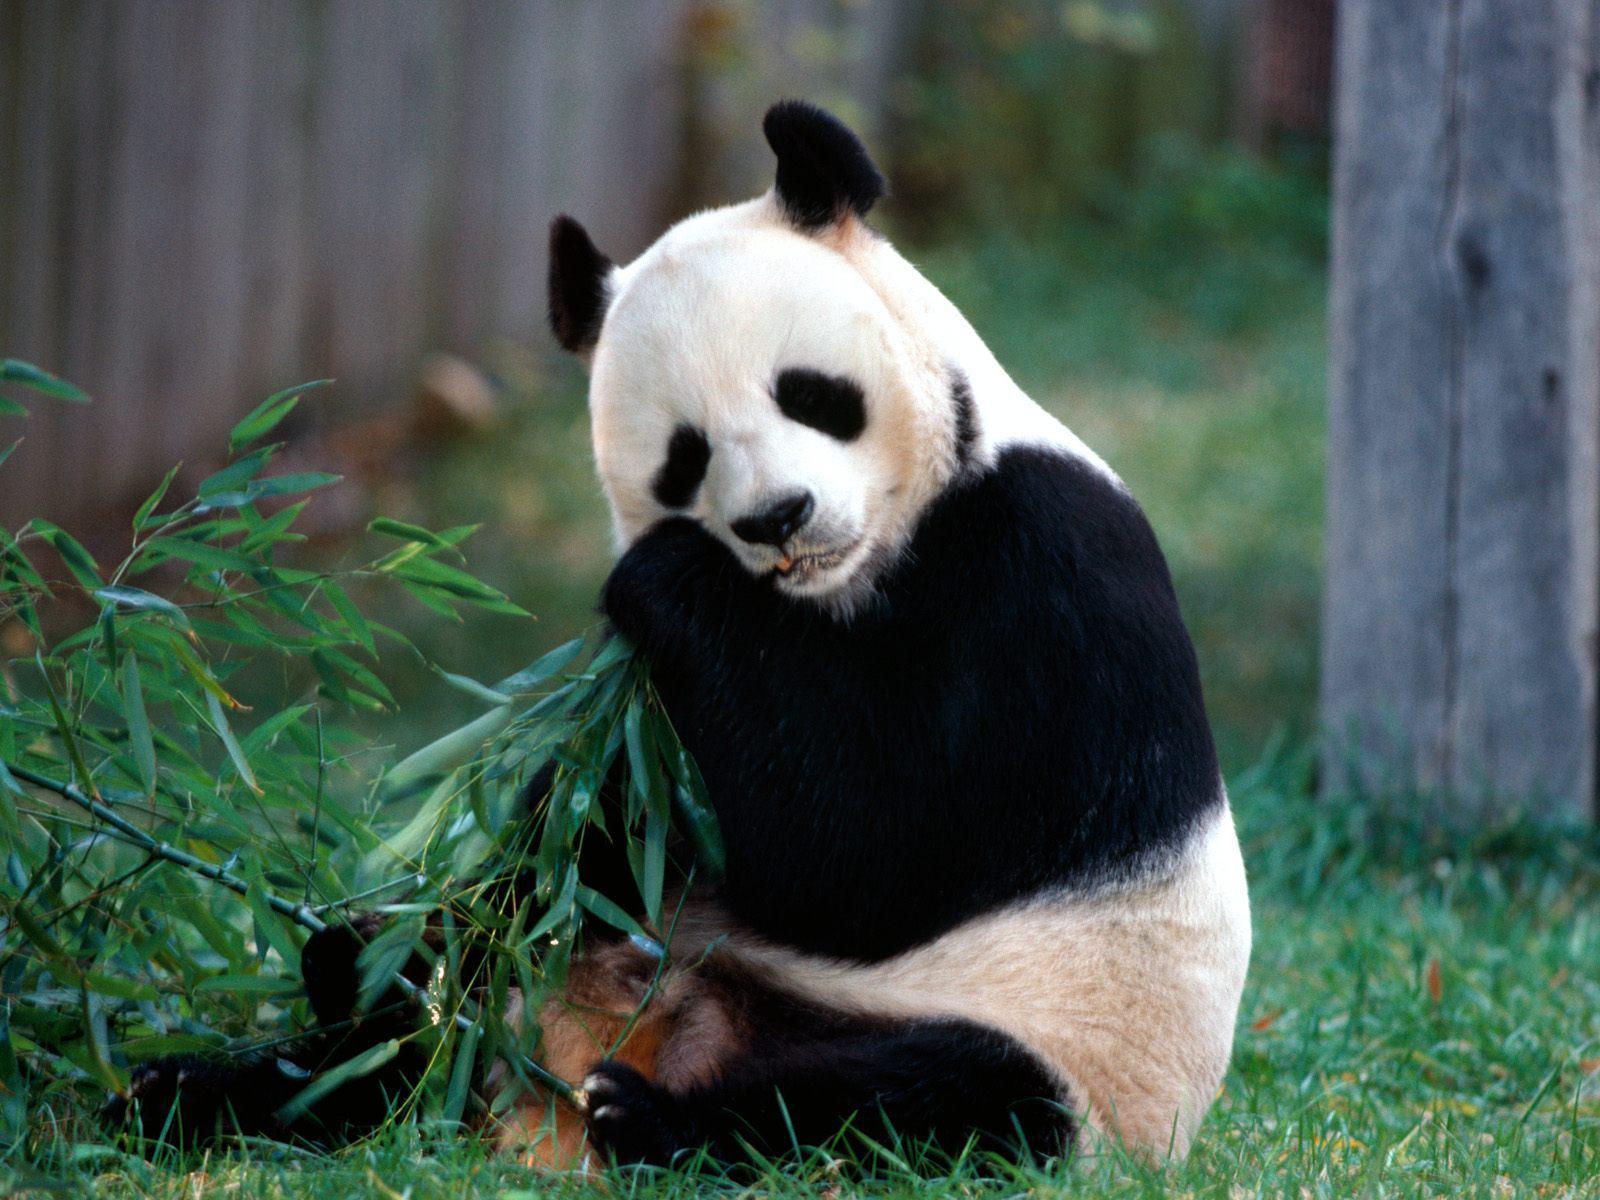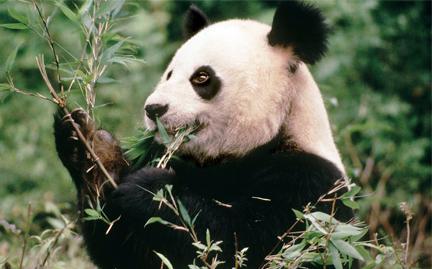The first image is the image on the left, the second image is the image on the right. For the images displayed, is the sentence "The right image shows two pandas." factually correct? Answer yes or no. No. 